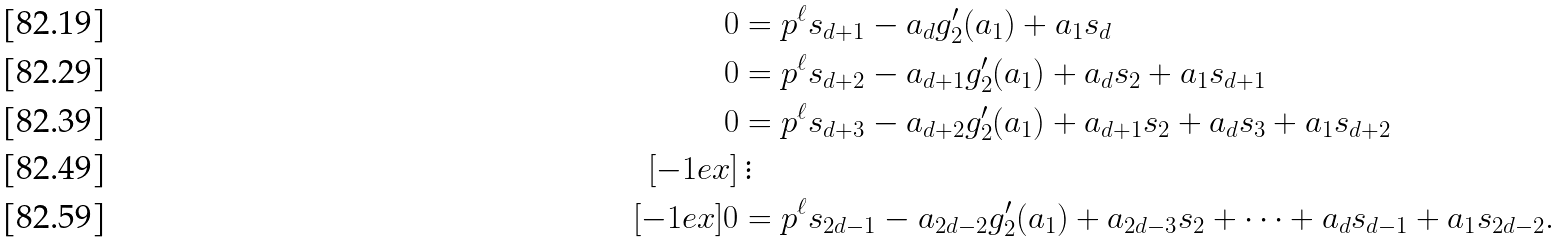<formula> <loc_0><loc_0><loc_500><loc_500>0 & = p ^ { \ell } s _ { d + 1 } - a _ { d } g _ { 2 } ^ { \prime } ( a _ { 1 } ) + a _ { 1 } s _ { d } \\ 0 & = p ^ { \ell } s _ { d + 2 } - a _ { d + 1 } g _ { 2 } ^ { \prime } ( a _ { 1 } ) + a _ { d } s _ { 2 } + a _ { 1 } s _ { d + 1 } \\ 0 & = p ^ { \ell } s _ { d + 3 } - a _ { d + 2 } g _ { 2 } ^ { \prime } ( a _ { 1 } ) + a _ { d + 1 } s _ { 2 } + a _ { d } s _ { 3 } + a _ { 1 } s _ { d + 2 } \\ [ - 1 e x ] & \, \vdots \\ [ - 1 e x ] 0 & = p ^ { \ell } s _ { 2 d - 1 } - a _ { 2 d - 2 } g _ { 2 } ^ { \prime } ( a _ { 1 } ) + a _ { 2 d - 3 } s _ { 2 } + \dots + a _ { d } s _ { d - 1 } + a _ { 1 } s _ { 2 d - 2 } .</formula> 